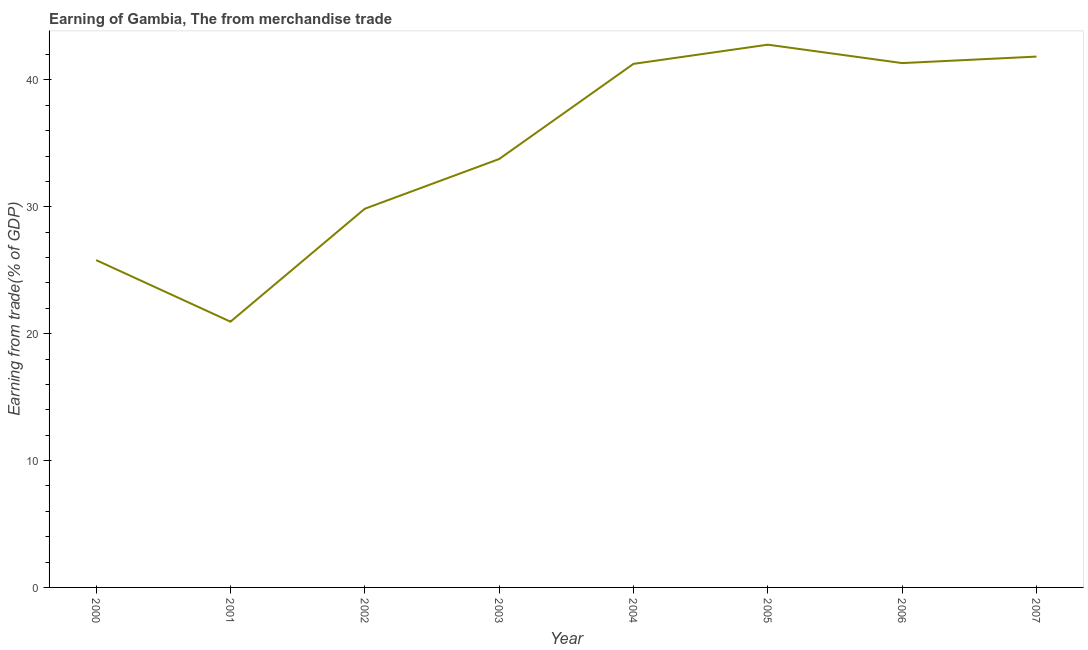What is the earning from merchandise trade in 2000?
Keep it short and to the point. 25.8. Across all years, what is the maximum earning from merchandise trade?
Your response must be concise. 42.78. Across all years, what is the minimum earning from merchandise trade?
Provide a short and direct response. 20.95. In which year was the earning from merchandise trade maximum?
Provide a succinct answer. 2005. What is the sum of the earning from merchandise trade?
Give a very brief answer. 277.6. What is the difference between the earning from merchandise trade in 2002 and 2007?
Your answer should be compact. -11.99. What is the average earning from merchandise trade per year?
Give a very brief answer. 34.7. What is the median earning from merchandise trade?
Provide a short and direct response. 37.52. In how many years, is the earning from merchandise trade greater than 28 %?
Give a very brief answer. 6. What is the ratio of the earning from merchandise trade in 2000 to that in 2005?
Provide a succinct answer. 0.6. What is the difference between the highest and the second highest earning from merchandise trade?
Give a very brief answer. 0.94. What is the difference between the highest and the lowest earning from merchandise trade?
Offer a terse response. 21.83. In how many years, is the earning from merchandise trade greater than the average earning from merchandise trade taken over all years?
Keep it short and to the point. 4. Does the earning from merchandise trade monotonically increase over the years?
Your answer should be very brief. No. How many lines are there?
Provide a succinct answer. 1. What is the difference between two consecutive major ticks on the Y-axis?
Provide a short and direct response. 10. Does the graph contain any zero values?
Offer a terse response. No. Does the graph contain grids?
Ensure brevity in your answer.  No. What is the title of the graph?
Ensure brevity in your answer.  Earning of Gambia, The from merchandise trade. What is the label or title of the X-axis?
Your response must be concise. Year. What is the label or title of the Y-axis?
Offer a very short reply. Earning from trade(% of GDP). What is the Earning from trade(% of GDP) in 2000?
Provide a succinct answer. 25.8. What is the Earning from trade(% of GDP) in 2001?
Make the answer very short. 20.95. What is the Earning from trade(% of GDP) in 2002?
Keep it short and to the point. 29.85. What is the Earning from trade(% of GDP) of 2003?
Your answer should be very brief. 33.77. What is the Earning from trade(% of GDP) in 2004?
Offer a terse response. 41.27. What is the Earning from trade(% of GDP) of 2005?
Ensure brevity in your answer.  42.78. What is the Earning from trade(% of GDP) of 2006?
Provide a succinct answer. 41.33. What is the Earning from trade(% of GDP) in 2007?
Make the answer very short. 41.84. What is the difference between the Earning from trade(% of GDP) in 2000 and 2001?
Offer a terse response. 4.85. What is the difference between the Earning from trade(% of GDP) in 2000 and 2002?
Ensure brevity in your answer.  -4.05. What is the difference between the Earning from trade(% of GDP) in 2000 and 2003?
Provide a short and direct response. -7.97. What is the difference between the Earning from trade(% of GDP) in 2000 and 2004?
Provide a succinct answer. -15.47. What is the difference between the Earning from trade(% of GDP) in 2000 and 2005?
Provide a succinct answer. -16.98. What is the difference between the Earning from trade(% of GDP) in 2000 and 2006?
Keep it short and to the point. -15.53. What is the difference between the Earning from trade(% of GDP) in 2000 and 2007?
Ensure brevity in your answer.  -16.04. What is the difference between the Earning from trade(% of GDP) in 2001 and 2002?
Make the answer very short. -8.9. What is the difference between the Earning from trade(% of GDP) in 2001 and 2003?
Give a very brief answer. -12.82. What is the difference between the Earning from trade(% of GDP) in 2001 and 2004?
Offer a very short reply. -20.32. What is the difference between the Earning from trade(% of GDP) in 2001 and 2005?
Your response must be concise. -21.83. What is the difference between the Earning from trade(% of GDP) in 2001 and 2006?
Your answer should be very brief. -20.38. What is the difference between the Earning from trade(% of GDP) in 2001 and 2007?
Ensure brevity in your answer.  -20.9. What is the difference between the Earning from trade(% of GDP) in 2002 and 2003?
Make the answer very short. -3.92. What is the difference between the Earning from trade(% of GDP) in 2002 and 2004?
Your answer should be very brief. -11.42. What is the difference between the Earning from trade(% of GDP) in 2002 and 2005?
Make the answer very short. -12.93. What is the difference between the Earning from trade(% of GDP) in 2002 and 2006?
Offer a very short reply. -11.48. What is the difference between the Earning from trade(% of GDP) in 2002 and 2007?
Offer a very short reply. -11.99. What is the difference between the Earning from trade(% of GDP) in 2003 and 2004?
Give a very brief answer. -7.5. What is the difference between the Earning from trade(% of GDP) in 2003 and 2005?
Give a very brief answer. -9.01. What is the difference between the Earning from trade(% of GDP) in 2003 and 2006?
Your response must be concise. -7.56. What is the difference between the Earning from trade(% of GDP) in 2003 and 2007?
Offer a terse response. -8.07. What is the difference between the Earning from trade(% of GDP) in 2004 and 2005?
Keep it short and to the point. -1.51. What is the difference between the Earning from trade(% of GDP) in 2004 and 2006?
Provide a short and direct response. -0.06. What is the difference between the Earning from trade(% of GDP) in 2004 and 2007?
Your answer should be compact. -0.57. What is the difference between the Earning from trade(% of GDP) in 2005 and 2006?
Make the answer very short. 1.45. What is the difference between the Earning from trade(% of GDP) in 2005 and 2007?
Offer a very short reply. 0.94. What is the difference between the Earning from trade(% of GDP) in 2006 and 2007?
Provide a succinct answer. -0.51. What is the ratio of the Earning from trade(% of GDP) in 2000 to that in 2001?
Ensure brevity in your answer.  1.23. What is the ratio of the Earning from trade(% of GDP) in 2000 to that in 2002?
Your answer should be very brief. 0.86. What is the ratio of the Earning from trade(% of GDP) in 2000 to that in 2003?
Keep it short and to the point. 0.76. What is the ratio of the Earning from trade(% of GDP) in 2000 to that in 2005?
Your answer should be very brief. 0.6. What is the ratio of the Earning from trade(% of GDP) in 2000 to that in 2006?
Ensure brevity in your answer.  0.62. What is the ratio of the Earning from trade(% of GDP) in 2000 to that in 2007?
Your answer should be very brief. 0.62. What is the ratio of the Earning from trade(% of GDP) in 2001 to that in 2002?
Make the answer very short. 0.7. What is the ratio of the Earning from trade(% of GDP) in 2001 to that in 2003?
Your answer should be compact. 0.62. What is the ratio of the Earning from trade(% of GDP) in 2001 to that in 2004?
Keep it short and to the point. 0.51. What is the ratio of the Earning from trade(% of GDP) in 2001 to that in 2005?
Provide a short and direct response. 0.49. What is the ratio of the Earning from trade(% of GDP) in 2001 to that in 2006?
Offer a terse response. 0.51. What is the ratio of the Earning from trade(% of GDP) in 2001 to that in 2007?
Make the answer very short. 0.5. What is the ratio of the Earning from trade(% of GDP) in 2002 to that in 2003?
Keep it short and to the point. 0.88. What is the ratio of the Earning from trade(% of GDP) in 2002 to that in 2004?
Make the answer very short. 0.72. What is the ratio of the Earning from trade(% of GDP) in 2002 to that in 2005?
Give a very brief answer. 0.7. What is the ratio of the Earning from trade(% of GDP) in 2002 to that in 2006?
Give a very brief answer. 0.72. What is the ratio of the Earning from trade(% of GDP) in 2002 to that in 2007?
Ensure brevity in your answer.  0.71. What is the ratio of the Earning from trade(% of GDP) in 2003 to that in 2004?
Provide a short and direct response. 0.82. What is the ratio of the Earning from trade(% of GDP) in 2003 to that in 2005?
Offer a terse response. 0.79. What is the ratio of the Earning from trade(% of GDP) in 2003 to that in 2006?
Your answer should be compact. 0.82. What is the ratio of the Earning from trade(% of GDP) in 2003 to that in 2007?
Make the answer very short. 0.81. What is the ratio of the Earning from trade(% of GDP) in 2004 to that in 2006?
Your answer should be compact. 1. What is the ratio of the Earning from trade(% of GDP) in 2005 to that in 2006?
Provide a short and direct response. 1.03. What is the ratio of the Earning from trade(% of GDP) in 2005 to that in 2007?
Provide a short and direct response. 1.02. What is the ratio of the Earning from trade(% of GDP) in 2006 to that in 2007?
Your response must be concise. 0.99. 